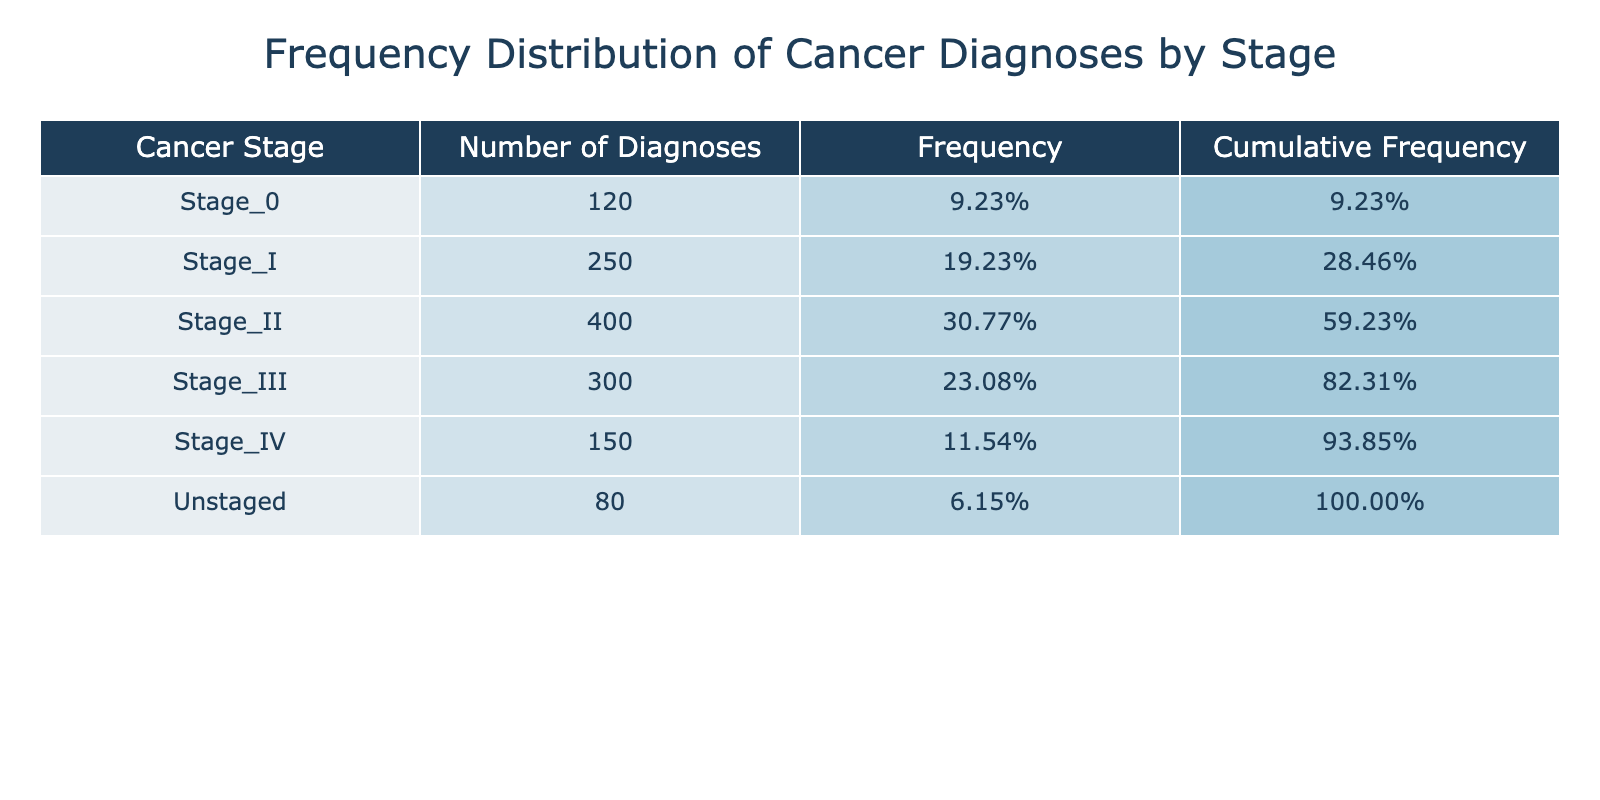What is the total number of cancer diagnoses recorded in the table? To find the total number of cancer diagnoses, I need to sum the values in the "Number_of_Diagnoses" column. The numbers are: 120 (Stage 0) + 250 (Stage I) + 400 (Stage II) + 300 (Stage III) + 150 (Stage IV) + 80 (Unstaged) = 1300.
Answer: 1300 Which cancer stage had the highest number of diagnoses? Looking at the "Number_of_Diagnoses" column, Stage II has the highest value at 400, comparing it with other stages.
Answer: Stage II What percentage of cancer diagnoses were at Stage IV? The number of diagnoses at Stage IV is 150. To find the percentage, I divide 150 by the total number of diagnoses (1300) and multiply by 100, which is (150/1300) * 100 = 11.54%.
Answer: 11.54% How many more diagnoses were there in Stage II compared to Stage IV? The number of diagnoses in Stage II is 400, while in Stage IV it is 150. I subtract the two values: 400 - 150 = 250.
Answer: 250 Is it true that there were more diagnoses in Stage I than Stage III? Stage I has 250 diagnoses and Stage III has 300. Since 250 is less than 300, the statement is false.
Answer: No What is the cumulative frequency of cancer diagnoses for Stages 0 and I combined? The cumulative frequency for Stage 0 is 120/1300 = 0.0923 and for Stage I it is (120 + 250)/1300 = 0.2846. Adding these gives 0.0923 + 0.1923 = 0.2846, or 28.46%.
Answer: 28.46% Which stage accounts for the least number of diagnoses according to the table? The "Number_of_Diagnoses" shows that Unstaged has the least value at 80 compared to the other stages.
Answer: Unstaged What proportion of the total diagnoses do Stages III and IV together represent? Stages III and IV together have 300 (Stage III) + 150 (Stage IV) = 450 diagnoses. Now, to find the proportion: 450 / 1300 = 0.3461 or 34.61%.
Answer: 34.61% How many of the total diagnoses were unstaged or at Stage 0? The total for Stages 0 and Unstaged is 120 (Stage 0) + 80 (Unstaged) = 200.
Answer: 200 